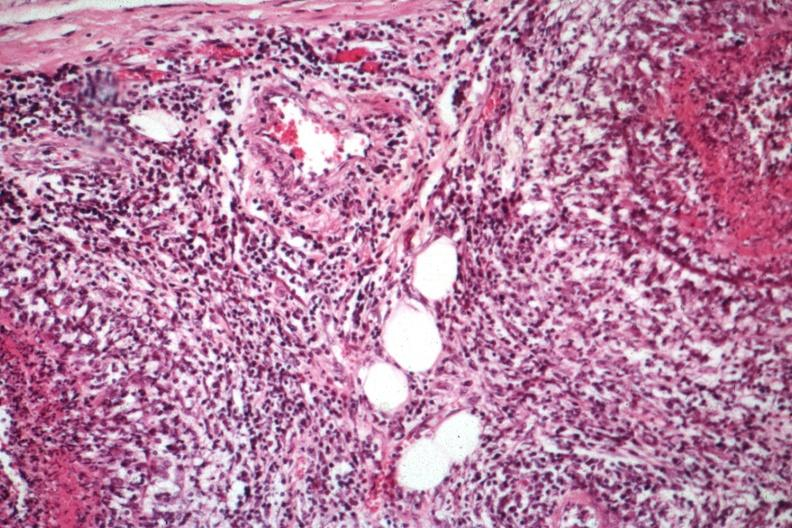does this image show fibrinoid vasculitis and inflammatory cell infiltrative vasculitis well shown?
Answer the question using a single word or phrase. Yes 